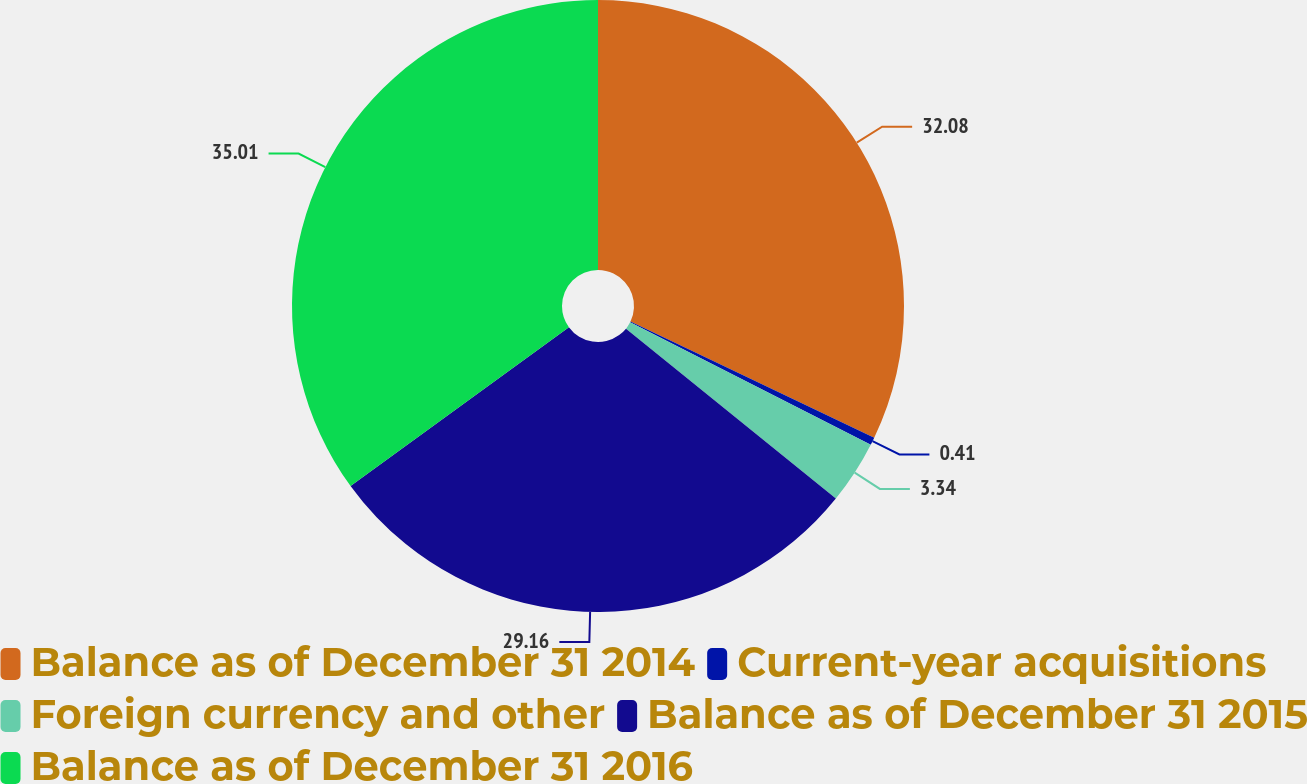<chart> <loc_0><loc_0><loc_500><loc_500><pie_chart><fcel>Balance as of December 31 2014<fcel>Current-year acquisitions<fcel>Foreign currency and other<fcel>Balance as of December 31 2015<fcel>Balance as of December 31 2016<nl><fcel>32.08%<fcel>0.41%<fcel>3.34%<fcel>29.16%<fcel>35.01%<nl></chart> 